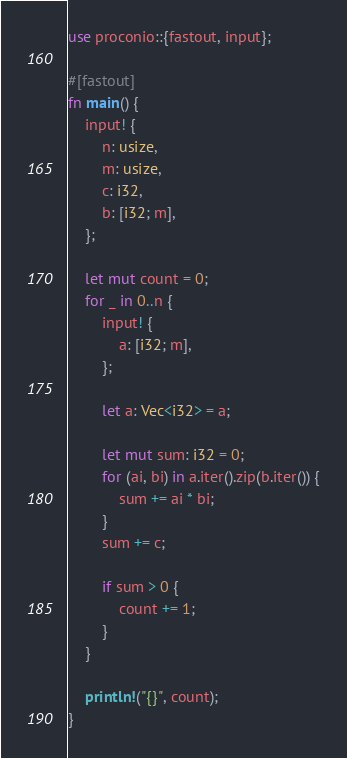<code> <loc_0><loc_0><loc_500><loc_500><_Rust_>use proconio::{fastout, input};

#[fastout]
fn main() {
    input! {
        n: usize,
        m: usize,
        c: i32,
        b: [i32; m],
    };

    let mut count = 0;
    for _ in 0..n {
        input! {
            a: [i32; m],
        };

        let a: Vec<i32> = a;

        let mut sum: i32 = 0;
        for (ai, bi) in a.iter().zip(b.iter()) {
            sum += ai * bi;
        }
        sum += c;

        if sum > 0 {
            count += 1;
        }
    }

    println!("{}", count);
}
</code> 